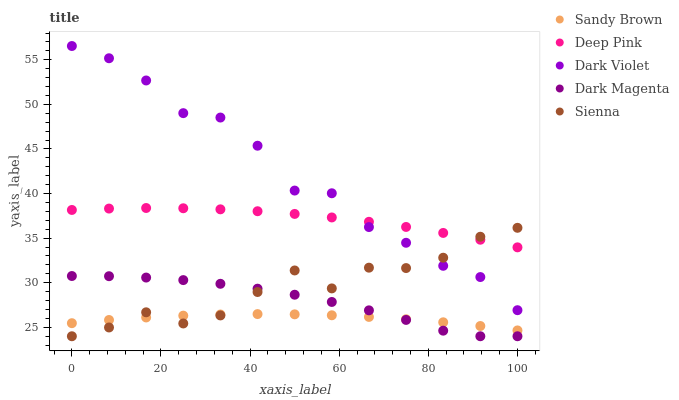Does Sandy Brown have the minimum area under the curve?
Answer yes or no. Yes. Does Dark Violet have the maximum area under the curve?
Answer yes or no. Yes. Does Deep Pink have the minimum area under the curve?
Answer yes or no. No. Does Deep Pink have the maximum area under the curve?
Answer yes or no. No. Is Sandy Brown the smoothest?
Answer yes or no. Yes. Is Dark Violet the roughest?
Answer yes or no. Yes. Is Deep Pink the smoothest?
Answer yes or no. No. Is Deep Pink the roughest?
Answer yes or no. No. Does Sienna have the lowest value?
Answer yes or no. Yes. Does Sandy Brown have the lowest value?
Answer yes or no. No. Does Dark Violet have the highest value?
Answer yes or no. Yes. Does Deep Pink have the highest value?
Answer yes or no. No. Is Sandy Brown less than Deep Pink?
Answer yes or no. Yes. Is Dark Violet greater than Dark Magenta?
Answer yes or no. Yes. Does Dark Violet intersect Deep Pink?
Answer yes or no. Yes. Is Dark Violet less than Deep Pink?
Answer yes or no. No. Is Dark Violet greater than Deep Pink?
Answer yes or no. No. Does Sandy Brown intersect Deep Pink?
Answer yes or no. No. 